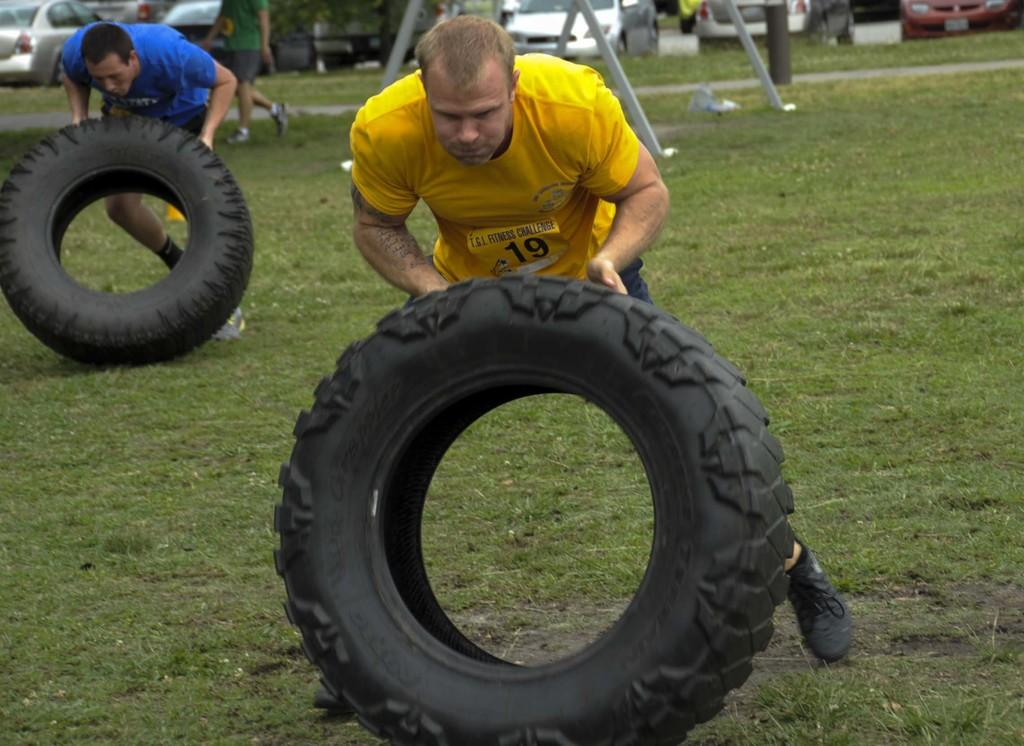How many men are in the image? There are two men in the image. What are the men doing in the image? The men are lifting tires in the image. What is the setting of the image? The scene is set on a grassland. What can be seen in the background of the image? There are cars, a man, and poles in the background of the image. What type of advice is the mitten giving to the wax in the image? There is no mitten or wax present in the image, so no such advice can be given. 